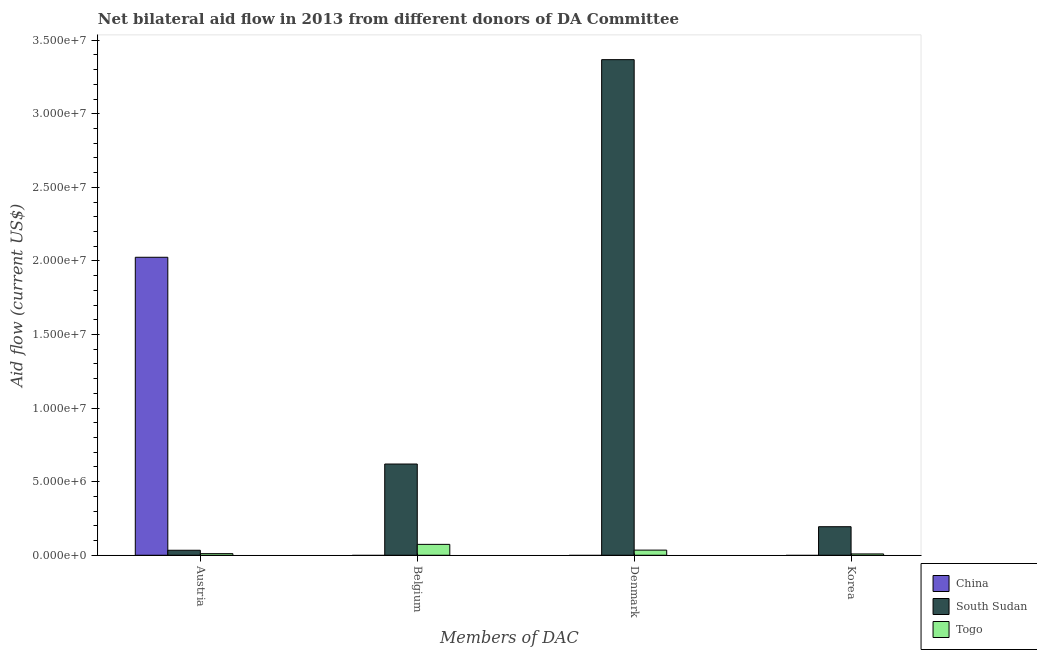How many different coloured bars are there?
Provide a succinct answer. 3. How many groups of bars are there?
Make the answer very short. 4. Are the number of bars on each tick of the X-axis equal?
Provide a short and direct response. No. How many bars are there on the 1st tick from the left?
Offer a very short reply. 3. What is the label of the 1st group of bars from the left?
Offer a very short reply. Austria. What is the amount of aid given by belgium in Togo?
Offer a terse response. 7.40e+05. Across all countries, what is the maximum amount of aid given by belgium?
Your response must be concise. 6.20e+06. Across all countries, what is the minimum amount of aid given by denmark?
Offer a very short reply. 0. In which country was the amount of aid given by denmark maximum?
Provide a short and direct response. South Sudan. What is the total amount of aid given by austria in the graph?
Make the answer very short. 2.07e+07. What is the difference between the amount of aid given by belgium in Togo and that in South Sudan?
Provide a succinct answer. -5.46e+06. What is the difference between the amount of aid given by korea in China and the amount of aid given by denmark in South Sudan?
Make the answer very short. -3.37e+07. What is the average amount of aid given by austria per country?
Keep it short and to the point. 6.90e+06. What is the difference between the amount of aid given by belgium and amount of aid given by austria in South Sudan?
Your answer should be very brief. 5.86e+06. In how many countries, is the amount of aid given by belgium greater than 34000000 US$?
Keep it short and to the point. 0. What is the ratio of the amount of aid given by korea in South Sudan to that in Togo?
Make the answer very short. 21.56. What is the difference between the highest and the second highest amount of aid given by austria?
Your answer should be compact. 1.99e+07. What is the difference between the highest and the lowest amount of aid given by korea?
Ensure brevity in your answer.  1.94e+06. In how many countries, is the amount of aid given by korea greater than the average amount of aid given by korea taken over all countries?
Offer a terse response. 1. Is it the case that in every country, the sum of the amount of aid given by austria and amount of aid given by belgium is greater than the amount of aid given by denmark?
Make the answer very short. No. Are all the bars in the graph horizontal?
Your answer should be very brief. No. How many countries are there in the graph?
Provide a succinct answer. 3. What is the difference between two consecutive major ticks on the Y-axis?
Provide a succinct answer. 5.00e+06. Are the values on the major ticks of Y-axis written in scientific E-notation?
Your answer should be very brief. Yes. Does the graph contain any zero values?
Your answer should be compact. Yes. Does the graph contain grids?
Ensure brevity in your answer.  No. What is the title of the graph?
Offer a very short reply. Net bilateral aid flow in 2013 from different donors of DA Committee. Does "Hungary" appear as one of the legend labels in the graph?
Keep it short and to the point. No. What is the label or title of the X-axis?
Your response must be concise. Members of DAC. What is the Aid flow (current US$) of China in Austria?
Give a very brief answer. 2.02e+07. What is the Aid flow (current US$) of China in Belgium?
Your response must be concise. 0. What is the Aid flow (current US$) in South Sudan in Belgium?
Keep it short and to the point. 6.20e+06. What is the Aid flow (current US$) of Togo in Belgium?
Offer a terse response. 7.40e+05. What is the Aid flow (current US$) in China in Denmark?
Give a very brief answer. 0. What is the Aid flow (current US$) in South Sudan in Denmark?
Your answer should be very brief. 3.37e+07. What is the Aid flow (current US$) of Togo in Denmark?
Provide a succinct answer. 3.50e+05. What is the Aid flow (current US$) of South Sudan in Korea?
Keep it short and to the point. 1.94e+06. Across all Members of DAC, what is the maximum Aid flow (current US$) of China?
Your response must be concise. 2.02e+07. Across all Members of DAC, what is the maximum Aid flow (current US$) in South Sudan?
Your response must be concise. 3.37e+07. Across all Members of DAC, what is the maximum Aid flow (current US$) in Togo?
Offer a very short reply. 7.40e+05. Across all Members of DAC, what is the minimum Aid flow (current US$) in China?
Offer a terse response. 0. Across all Members of DAC, what is the minimum Aid flow (current US$) of South Sudan?
Give a very brief answer. 3.40e+05. Across all Members of DAC, what is the minimum Aid flow (current US$) in Togo?
Make the answer very short. 9.00e+04. What is the total Aid flow (current US$) in China in the graph?
Ensure brevity in your answer.  2.02e+07. What is the total Aid flow (current US$) of South Sudan in the graph?
Offer a terse response. 4.22e+07. What is the total Aid flow (current US$) of Togo in the graph?
Offer a terse response. 1.29e+06. What is the difference between the Aid flow (current US$) in South Sudan in Austria and that in Belgium?
Your answer should be very brief. -5.86e+06. What is the difference between the Aid flow (current US$) in Togo in Austria and that in Belgium?
Ensure brevity in your answer.  -6.30e+05. What is the difference between the Aid flow (current US$) in South Sudan in Austria and that in Denmark?
Provide a short and direct response. -3.33e+07. What is the difference between the Aid flow (current US$) of South Sudan in Austria and that in Korea?
Your answer should be compact. -1.60e+06. What is the difference between the Aid flow (current US$) of South Sudan in Belgium and that in Denmark?
Provide a succinct answer. -2.75e+07. What is the difference between the Aid flow (current US$) of South Sudan in Belgium and that in Korea?
Provide a short and direct response. 4.26e+06. What is the difference between the Aid flow (current US$) in Togo in Belgium and that in Korea?
Offer a terse response. 6.50e+05. What is the difference between the Aid flow (current US$) of South Sudan in Denmark and that in Korea?
Provide a succinct answer. 3.17e+07. What is the difference between the Aid flow (current US$) of Togo in Denmark and that in Korea?
Keep it short and to the point. 2.60e+05. What is the difference between the Aid flow (current US$) of China in Austria and the Aid flow (current US$) of South Sudan in Belgium?
Give a very brief answer. 1.40e+07. What is the difference between the Aid flow (current US$) of China in Austria and the Aid flow (current US$) of Togo in Belgium?
Provide a short and direct response. 1.95e+07. What is the difference between the Aid flow (current US$) in South Sudan in Austria and the Aid flow (current US$) in Togo in Belgium?
Offer a very short reply. -4.00e+05. What is the difference between the Aid flow (current US$) in China in Austria and the Aid flow (current US$) in South Sudan in Denmark?
Ensure brevity in your answer.  -1.34e+07. What is the difference between the Aid flow (current US$) in China in Austria and the Aid flow (current US$) in Togo in Denmark?
Your response must be concise. 1.99e+07. What is the difference between the Aid flow (current US$) in South Sudan in Austria and the Aid flow (current US$) in Togo in Denmark?
Your answer should be very brief. -10000. What is the difference between the Aid flow (current US$) of China in Austria and the Aid flow (current US$) of South Sudan in Korea?
Ensure brevity in your answer.  1.83e+07. What is the difference between the Aid flow (current US$) in China in Austria and the Aid flow (current US$) in Togo in Korea?
Offer a terse response. 2.02e+07. What is the difference between the Aid flow (current US$) of South Sudan in Belgium and the Aid flow (current US$) of Togo in Denmark?
Keep it short and to the point. 5.85e+06. What is the difference between the Aid flow (current US$) of South Sudan in Belgium and the Aid flow (current US$) of Togo in Korea?
Provide a succinct answer. 6.11e+06. What is the difference between the Aid flow (current US$) of South Sudan in Denmark and the Aid flow (current US$) of Togo in Korea?
Your answer should be compact. 3.36e+07. What is the average Aid flow (current US$) in China per Members of DAC?
Provide a succinct answer. 5.06e+06. What is the average Aid flow (current US$) of South Sudan per Members of DAC?
Make the answer very short. 1.05e+07. What is the average Aid flow (current US$) of Togo per Members of DAC?
Keep it short and to the point. 3.22e+05. What is the difference between the Aid flow (current US$) of China and Aid flow (current US$) of South Sudan in Austria?
Make the answer very short. 1.99e+07. What is the difference between the Aid flow (current US$) of China and Aid flow (current US$) of Togo in Austria?
Offer a terse response. 2.01e+07. What is the difference between the Aid flow (current US$) of South Sudan and Aid flow (current US$) of Togo in Austria?
Your answer should be very brief. 2.30e+05. What is the difference between the Aid flow (current US$) in South Sudan and Aid flow (current US$) in Togo in Belgium?
Make the answer very short. 5.46e+06. What is the difference between the Aid flow (current US$) in South Sudan and Aid flow (current US$) in Togo in Denmark?
Give a very brief answer. 3.33e+07. What is the difference between the Aid flow (current US$) of South Sudan and Aid flow (current US$) of Togo in Korea?
Ensure brevity in your answer.  1.85e+06. What is the ratio of the Aid flow (current US$) in South Sudan in Austria to that in Belgium?
Ensure brevity in your answer.  0.05. What is the ratio of the Aid flow (current US$) in Togo in Austria to that in Belgium?
Offer a terse response. 0.15. What is the ratio of the Aid flow (current US$) in South Sudan in Austria to that in Denmark?
Ensure brevity in your answer.  0.01. What is the ratio of the Aid flow (current US$) of Togo in Austria to that in Denmark?
Give a very brief answer. 0.31. What is the ratio of the Aid flow (current US$) of South Sudan in Austria to that in Korea?
Offer a terse response. 0.18. What is the ratio of the Aid flow (current US$) in Togo in Austria to that in Korea?
Make the answer very short. 1.22. What is the ratio of the Aid flow (current US$) in South Sudan in Belgium to that in Denmark?
Your response must be concise. 0.18. What is the ratio of the Aid flow (current US$) of Togo in Belgium to that in Denmark?
Provide a short and direct response. 2.11. What is the ratio of the Aid flow (current US$) in South Sudan in Belgium to that in Korea?
Provide a succinct answer. 3.2. What is the ratio of the Aid flow (current US$) in Togo in Belgium to that in Korea?
Ensure brevity in your answer.  8.22. What is the ratio of the Aid flow (current US$) of South Sudan in Denmark to that in Korea?
Ensure brevity in your answer.  17.36. What is the ratio of the Aid flow (current US$) of Togo in Denmark to that in Korea?
Offer a very short reply. 3.89. What is the difference between the highest and the second highest Aid flow (current US$) of South Sudan?
Your answer should be compact. 2.75e+07. What is the difference between the highest and the lowest Aid flow (current US$) in China?
Provide a short and direct response. 2.02e+07. What is the difference between the highest and the lowest Aid flow (current US$) of South Sudan?
Your answer should be very brief. 3.33e+07. What is the difference between the highest and the lowest Aid flow (current US$) of Togo?
Your answer should be very brief. 6.50e+05. 